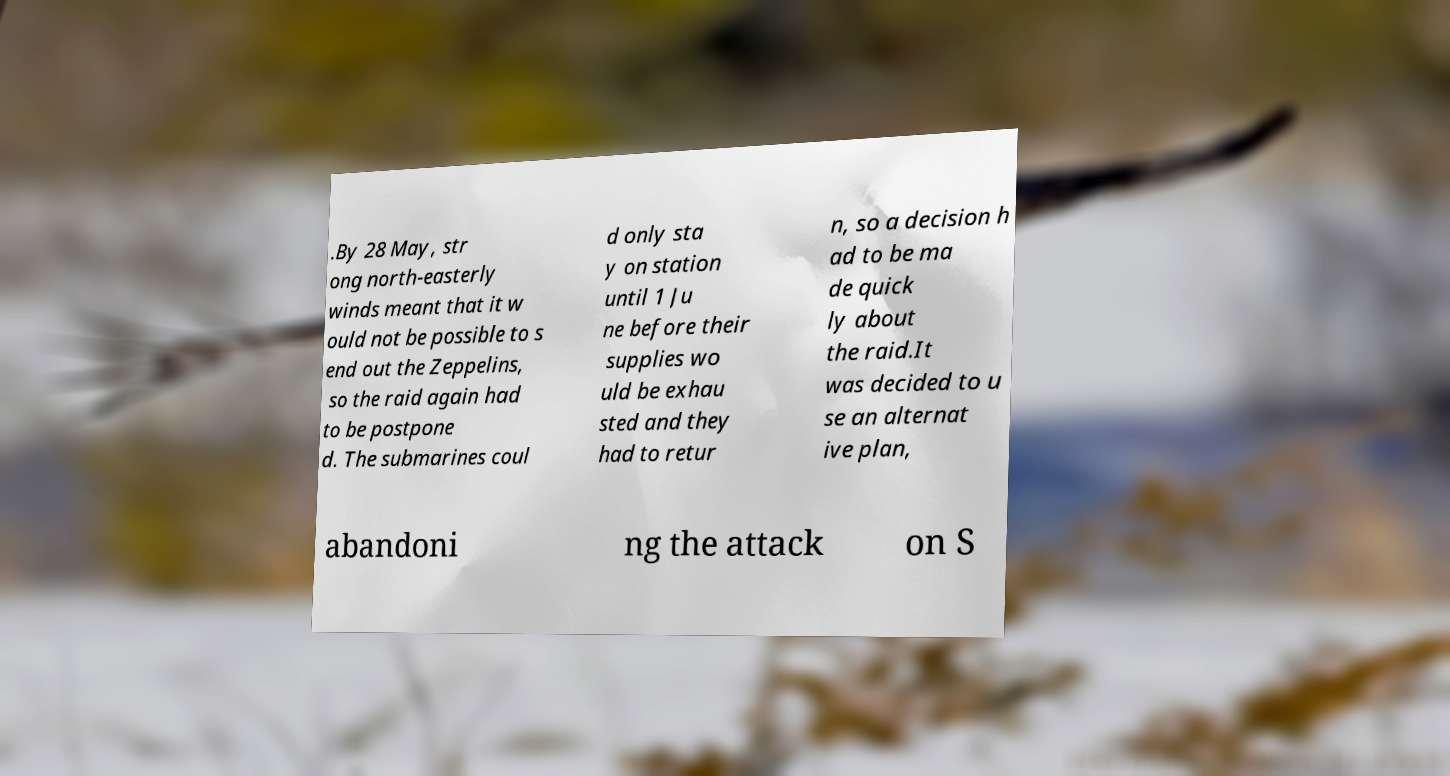Could you extract and type out the text from this image? .By 28 May, str ong north-easterly winds meant that it w ould not be possible to s end out the Zeppelins, so the raid again had to be postpone d. The submarines coul d only sta y on station until 1 Ju ne before their supplies wo uld be exhau sted and they had to retur n, so a decision h ad to be ma de quick ly about the raid.It was decided to u se an alternat ive plan, abandoni ng the attack on S 